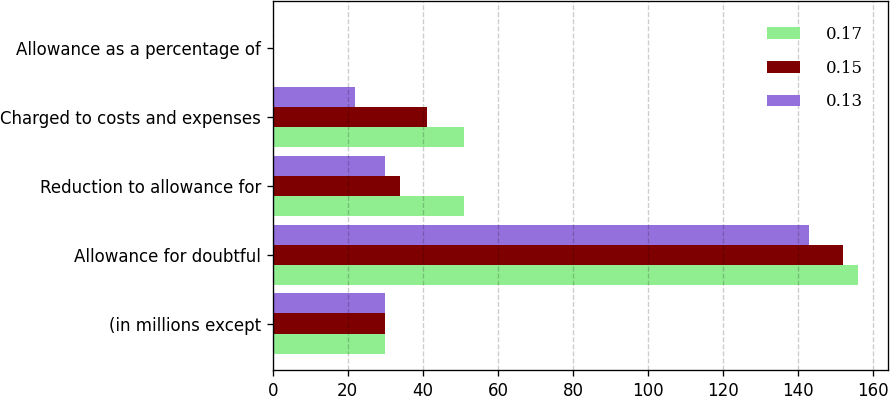Convert chart to OTSL. <chart><loc_0><loc_0><loc_500><loc_500><stacked_bar_chart><ecel><fcel>(in millions except<fcel>Allowance for doubtful<fcel>Reduction to allowance for<fcel>Charged to costs and expenses<fcel>Allowance as a percentage of<nl><fcel>0.17<fcel>30<fcel>156<fcel>51<fcel>51<fcel>0.17<nl><fcel>0.15<fcel>30<fcel>152<fcel>34<fcel>41<fcel>0.15<nl><fcel>0.13<fcel>30<fcel>143<fcel>30<fcel>22<fcel>0.13<nl></chart> 